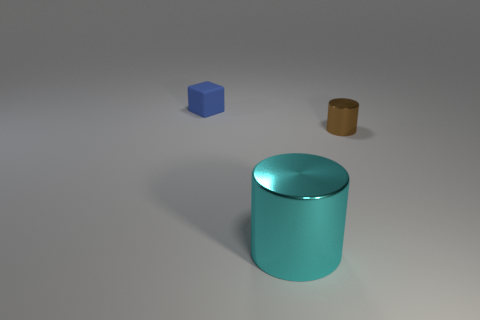Can you guess the texture of the objects? While it's not possible to feel texture through an image, visually, the objects appear to have smooth surfaces. The way the light reflects off the teal cylinder and the blue cube suggests a potentially glossy or plastic-like texture. The brown object has a more muted reflection, which might suggest a less shiny, perhaps a more matte or paper-like texture. 